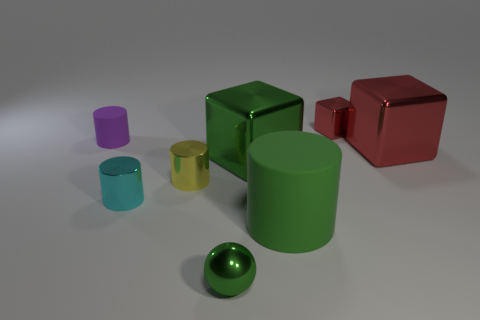Is there a small metal cylinder of the same color as the metallic sphere?
Keep it short and to the point. No. How many things are either tiny green objects that are in front of the small yellow object or cylinders to the right of the small purple object?
Provide a short and direct response. 4. Is the metal sphere the same color as the big rubber thing?
Keep it short and to the point. Yes. There is a ball that is the same color as the large cylinder; what material is it?
Give a very brief answer. Metal. Are there fewer cyan objects that are behind the small yellow metal object than small metallic objects to the left of the green ball?
Your response must be concise. Yes. Does the large green cylinder have the same material as the small cyan cylinder?
Your answer should be very brief. No. There is a green object that is both in front of the yellow shiny cylinder and behind the tiny green ball; how big is it?
Give a very brief answer. Large. The purple matte object that is the same size as the cyan cylinder is what shape?
Your response must be concise. Cylinder. The small cylinder that is behind the big block that is on the right side of the small object that is to the right of the green metallic ball is made of what material?
Provide a succinct answer. Rubber. There is a small rubber object behind the large red shiny block; is it the same shape as the green metallic thing that is behind the tiny green shiny object?
Ensure brevity in your answer.  No. 